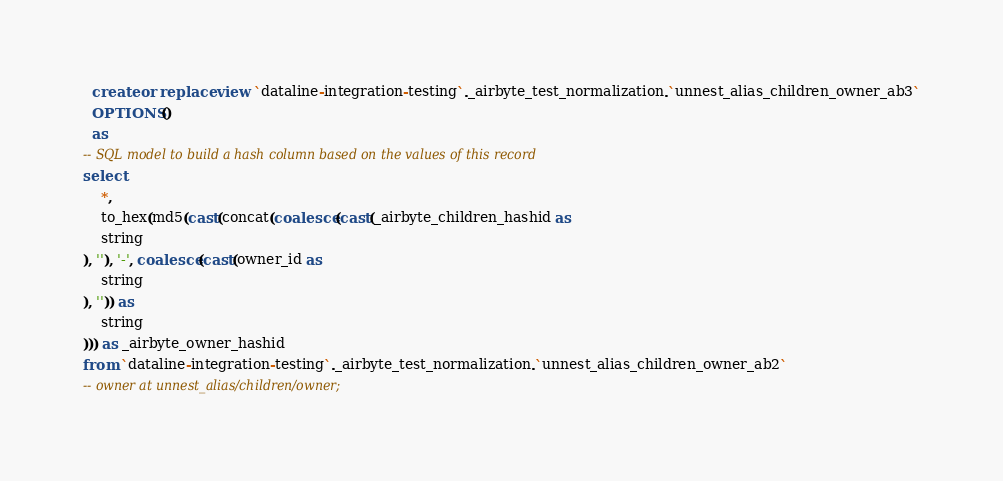Convert code to text. <code><loc_0><loc_0><loc_500><loc_500><_SQL_>

  create or replace view `dataline-integration-testing`._airbyte_test_normalization.`unnest_alias_children_owner_ab3`
  OPTIONS()
  as 
-- SQL model to build a hash column based on the values of this record
select
    *,
    to_hex(md5(cast(concat(coalesce(cast(_airbyte_children_hashid as 
    string
), ''), '-', coalesce(cast(owner_id as 
    string
), '')) as 
    string
))) as _airbyte_owner_hashid
from `dataline-integration-testing`._airbyte_test_normalization.`unnest_alias_children_owner_ab2`
-- owner at unnest_alias/children/owner;

</code> 